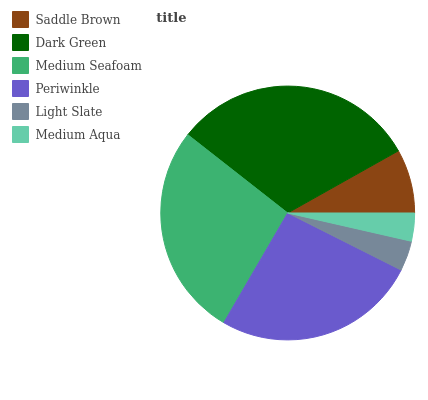Is Medium Aqua the minimum?
Answer yes or no. Yes. Is Dark Green the maximum?
Answer yes or no. Yes. Is Medium Seafoam the minimum?
Answer yes or no. No. Is Medium Seafoam the maximum?
Answer yes or no. No. Is Dark Green greater than Medium Seafoam?
Answer yes or no. Yes. Is Medium Seafoam less than Dark Green?
Answer yes or no. Yes. Is Medium Seafoam greater than Dark Green?
Answer yes or no. No. Is Dark Green less than Medium Seafoam?
Answer yes or no. No. Is Periwinkle the high median?
Answer yes or no. Yes. Is Saddle Brown the low median?
Answer yes or no. Yes. Is Saddle Brown the high median?
Answer yes or no. No. Is Dark Green the low median?
Answer yes or no. No. 